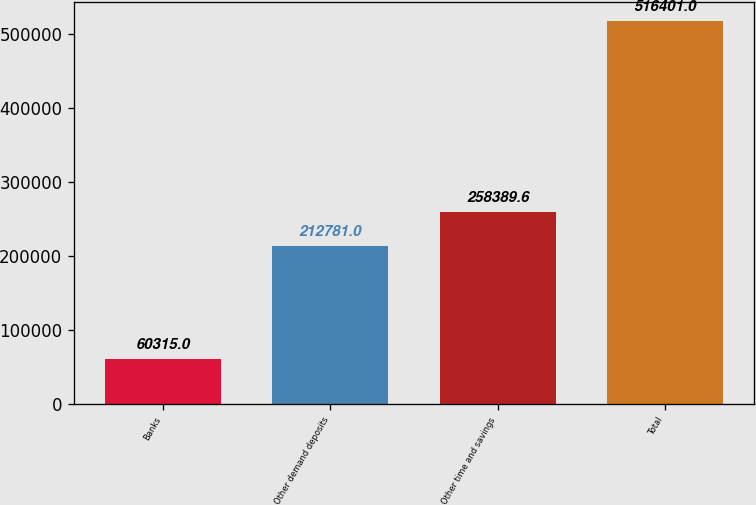Convert chart. <chart><loc_0><loc_0><loc_500><loc_500><bar_chart><fcel>Banks<fcel>Other demand deposits<fcel>Other time and savings<fcel>Total<nl><fcel>60315<fcel>212781<fcel>258390<fcel>516401<nl></chart> 